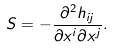Convert formula to latex. <formula><loc_0><loc_0><loc_500><loc_500>S = - \frac { \partial ^ { 2 } h _ { i j } } { \partial x ^ { i } \partial x ^ { j } } .</formula> 